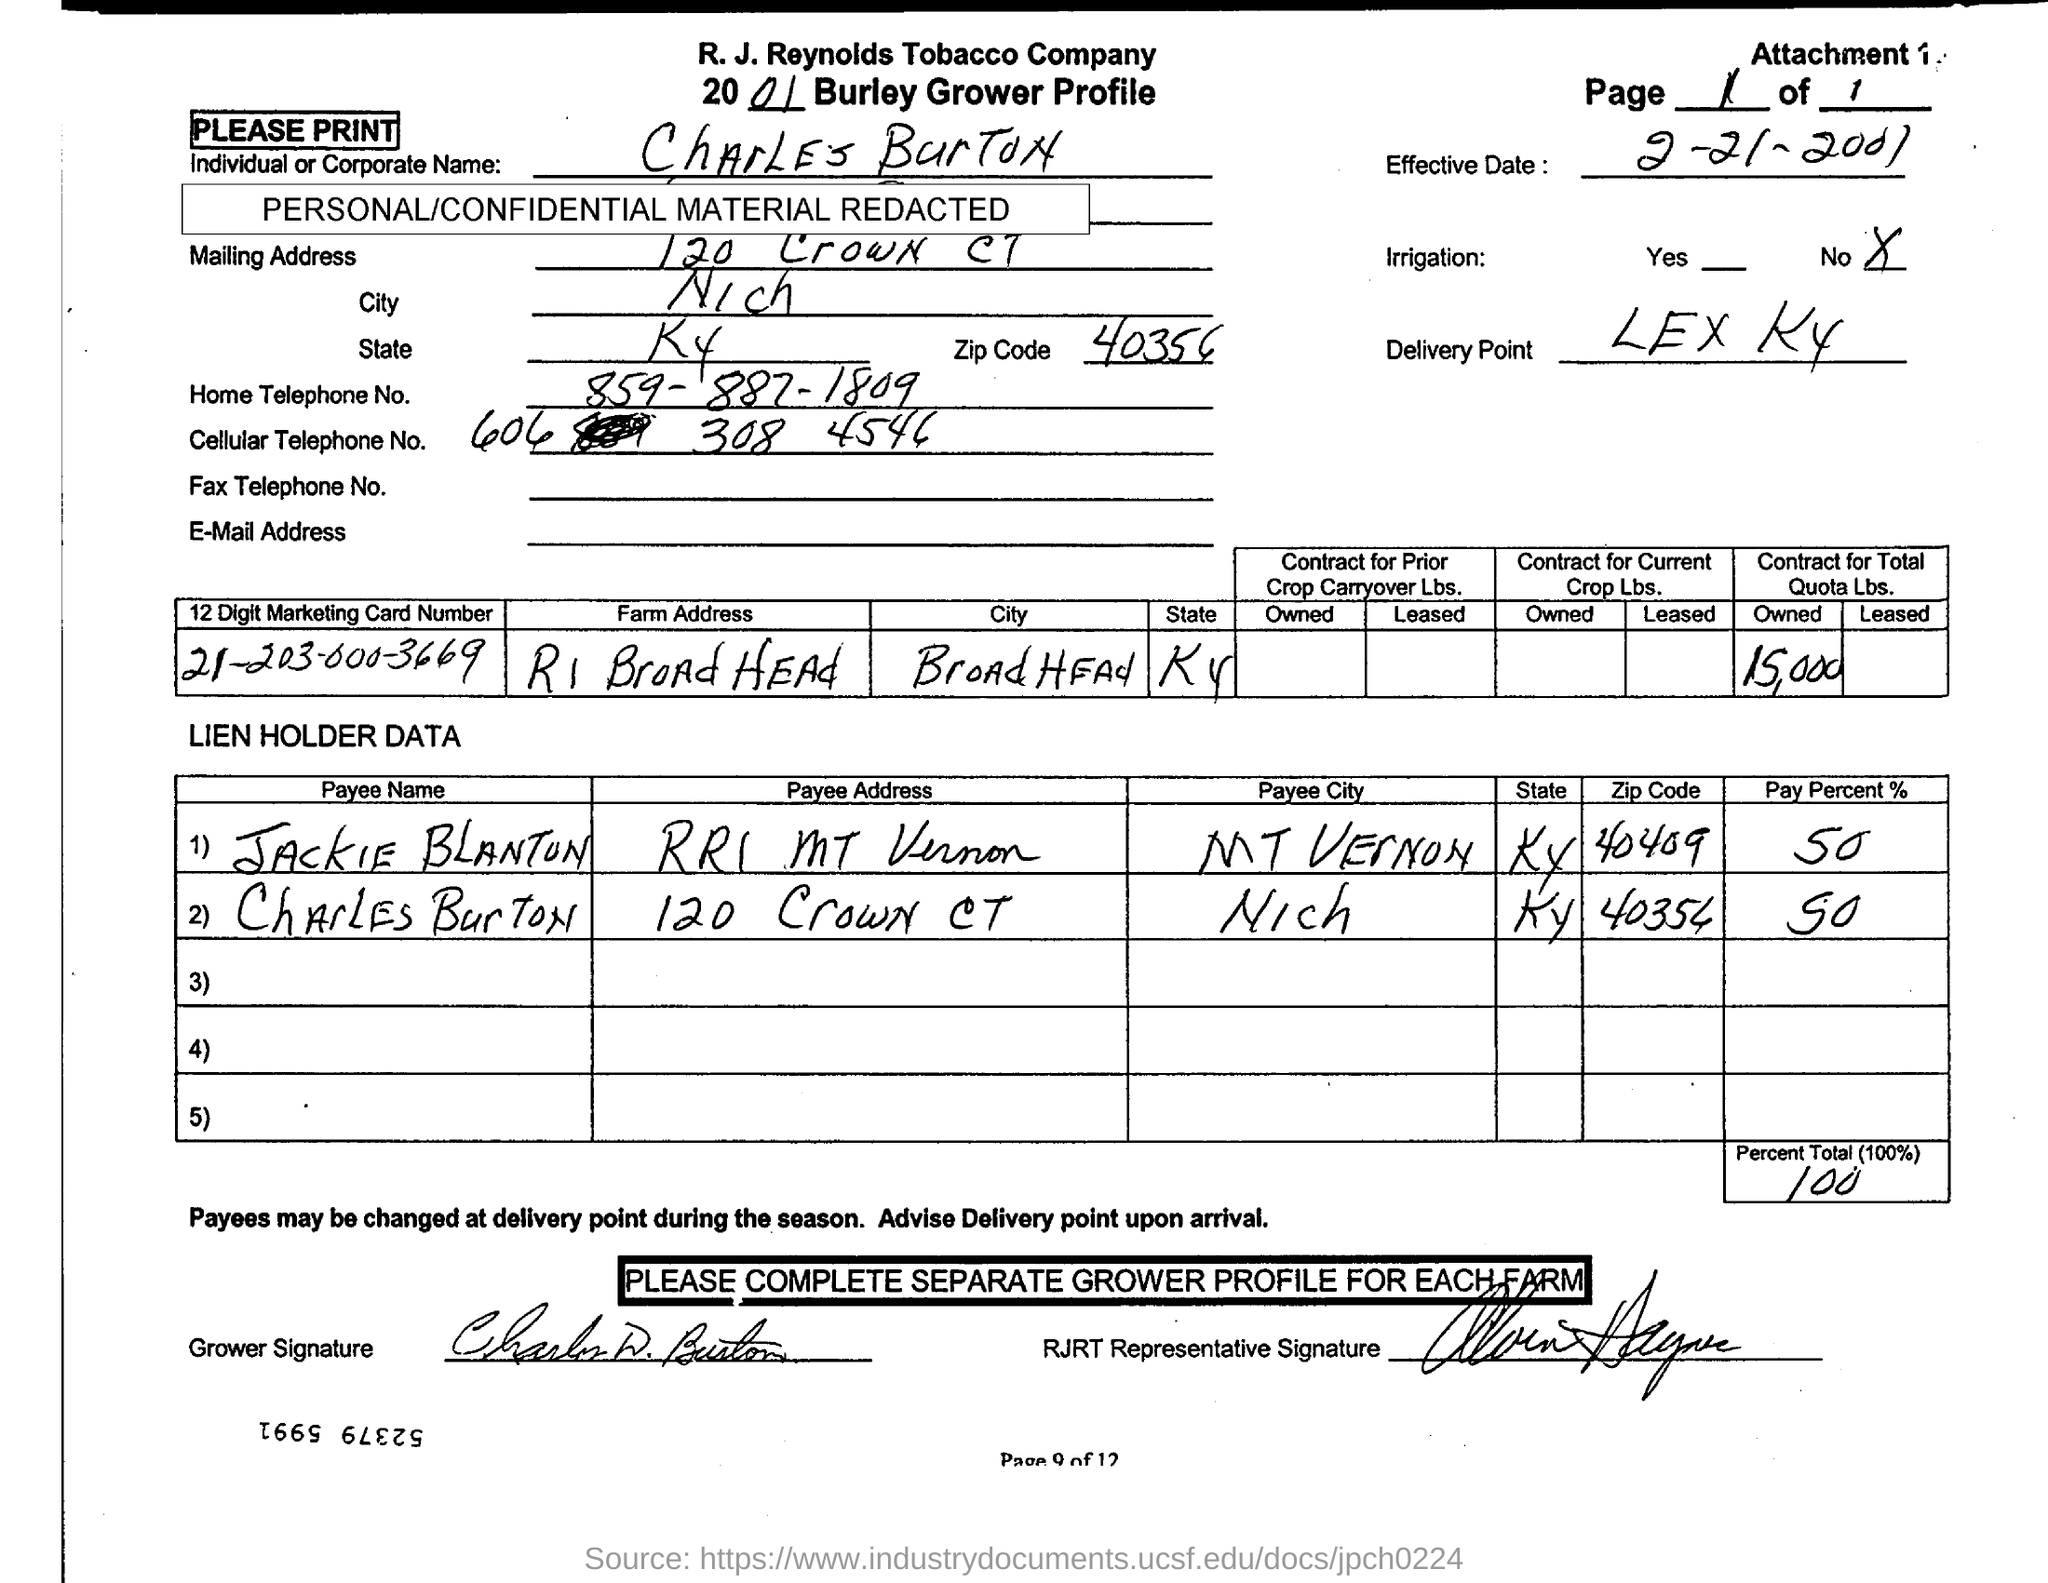Name the Indiviual or Corporate ?
Provide a succinct answer. Charles burton. What is the delivery point?
Your answer should be very brief. LEX KY. What is the Pay percent in total?
Your response must be concise. 100. What is the 12 digit Marketing Card Number?
Keep it short and to the point. 21-203-000-3669. What's the name of second Payee?
Offer a terse response. Charles burton. What is the Pay Percent to JACKIE BLANTON?
Provide a succinct answer. 50. Mention the owned  Quota Lbs. contract in total?
Provide a short and direct response. 15,000. 